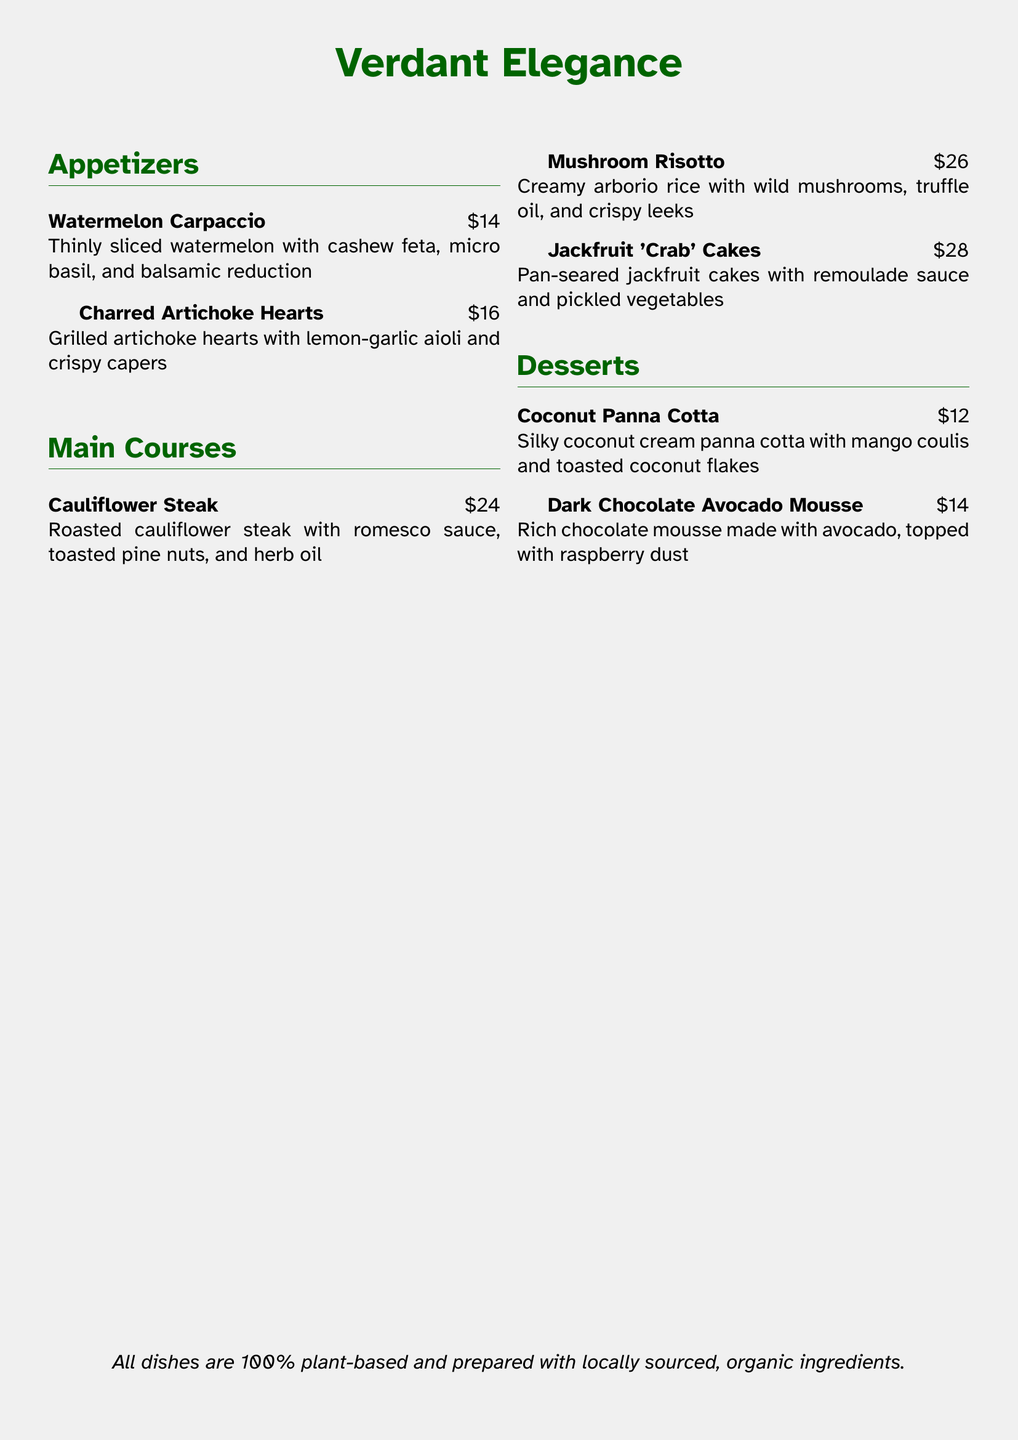what is the name of the restaurant? The name of the restaurant is prominently displayed at the top of the menu.
Answer: Verdant Elegance how much does the Watermelon Carpaccio cost? The cost of the Watermelon Carpaccio is listed next to its description.
Answer: $14 what is the main ingredient in the Jackfruit 'Crab' Cakes? The main ingredient is revealed in the title of the dish.
Answer: Jackfruit which dessert features mango coulis? The dessert description indicates which one includes mango coulis.
Answer: Coconut Panna Cotta how many appetizers are listed on the menu? The menu sections show the number of appetizers provided.
Answer: 2 what sauce is served with the Mushroom Risotto? The details in the dish description specify the sauce.
Answer: Truffle oil what is the total price of the main courses listed? The total price can be calculated by summing the prices of each main course.
Answer: $78 which ingredient is used for the Dark Chocolate Avocado Mousse? The mousse description identifies the ingredient used.
Answer: Avocado what type of cuisine does this menu feature? The menu’s introduction notes the cuisine type clearly.
Answer: Plant-based 